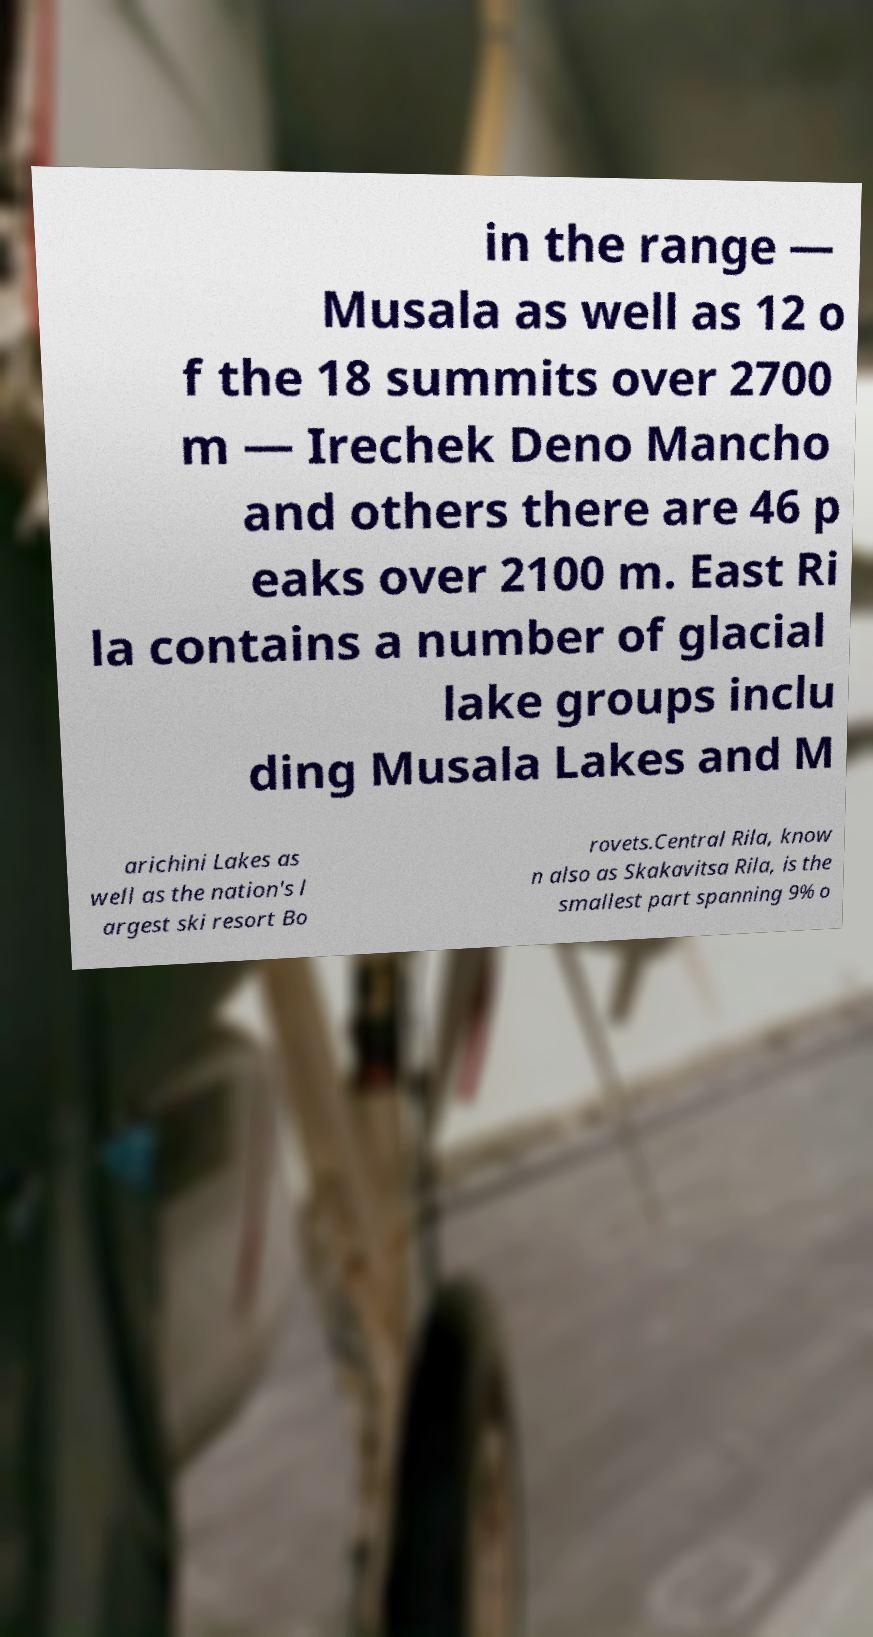Can you accurately transcribe the text from the provided image for me? in the range — Musala as well as 12 o f the 18 summits over 2700 m — Irechek Deno Mancho and others there are 46 p eaks over 2100 m. East Ri la contains a number of glacial lake groups inclu ding Musala Lakes and M arichini Lakes as well as the nation's l argest ski resort Bo rovets.Central Rila, know n also as Skakavitsa Rila, is the smallest part spanning 9% o 